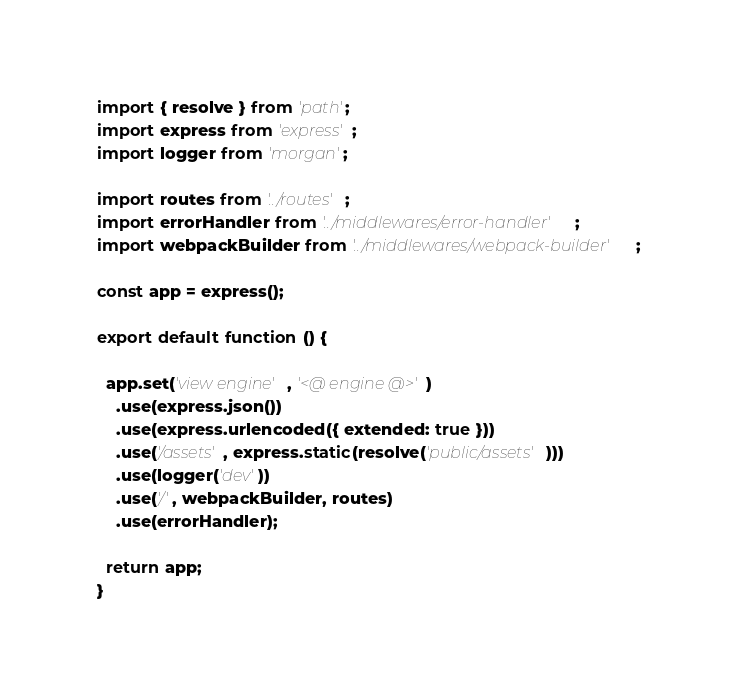<code> <loc_0><loc_0><loc_500><loc_500><_JavaScript_>import { resolve } from 'path';
import express from 'express';
import logger from 'morgan';

import routes from '../routes';
import errorHandler from '../middlewares/error-handler';
import webpackBuilder from '../middlewares/webpack-builder';

const app = express();

export default function () {

  app.set('view engine', '<@ engine @>')
    .use(express.json())
    .use(express.urlencoded({ extended: true }))
    .use('/assets', express.static(resolve('public/assets')))
    .use(logger('dev'))
    .use('/', webpackBuilder, routes)
    .use(errorHandler);

  return app;
}
</code> 